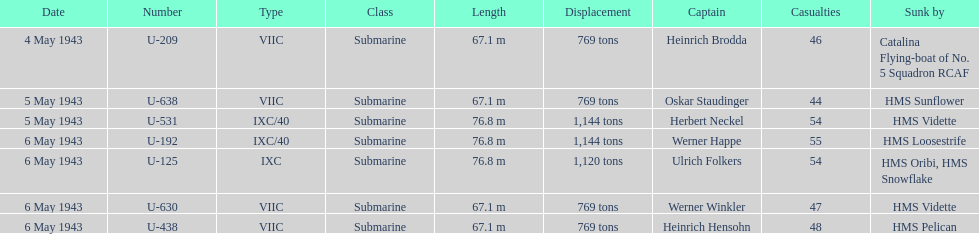Which u-boat had more than 54 casualties? U-192. 